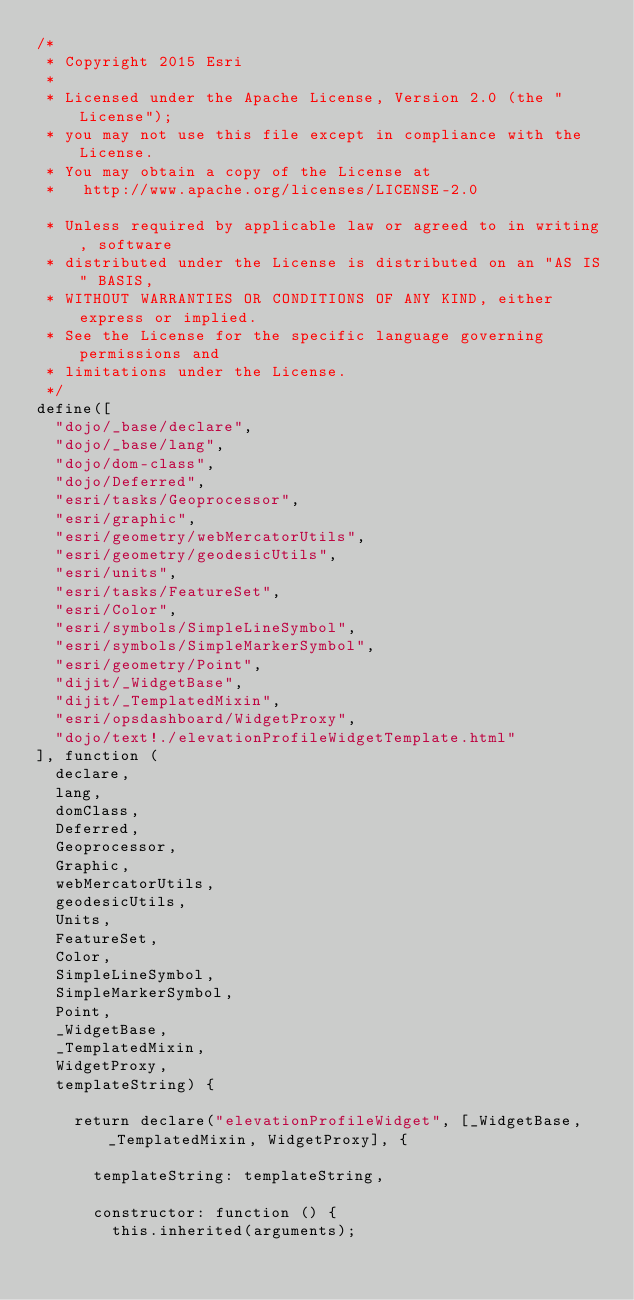Convert code to text. <code><loc_0><loc_0><loc_500><loc_500><_JavaScript_>/*
 * Copyright 2015 Esri
 *
 * Licensed under the Apache License, Version 2.0 (the "License");
 * you may not use this file except in compliance with the License.
 * You may obtain a copy of the License at
 *   http://www.apache.org/licenses/LICENSE-2.0

 * Unless required by applicable law or agreed to in writing, software
 * distributed under the License is distributed on an "AS IS" BASIS,
 * WITHOUT WARRANTIES OR CONDITIONS OF ANY KIND, either express or implied.
 * See the License for the specific language governing permissions and
 * limitations under the License.
 */
define([
  "dojo/_base/declare",
  "dojo/_base/lang",
  "dojo/dom-class",
  "dojo/Deferred",
  "esri/tasks/Geoprocessor",
  "esri/graphic",
  "esri/geometry/webMercatorUtils",
  "esri/geometry/geodesicUtils",
  "esri/units",
  "esri/tasks/FeatureSet",
  "esri/Color",
  "esri/symbols/SimpleLineSymbol",
  "esri/symbols/SimpleMarkerSymbol",
  "esri/geometry/Point",
  "dijit/_WidgetBase",
  "dijit/_TemplatedMixin",
  "esri/opsdashboard/WidgetProxy",
  "dojo/text!./elevationProfileWidgetTemplate.html"
], function (
  declare,
  lang,
  domClass,
  Deferred,
  Geoprocessor,
  Graphic,
  webMercatorUtils,
  geodesicUtils,
  Units,
  FeatureSet,
  Color,
  SimpleLineSymbol,
  SimpleMarkerSymbol,
  Point,
  _WidgetBase,
  _TemplatedMixin,
  WidgetProxy,
  templateString) {
    
    return declare("elevationProfileWidget", [_WidgetBase, _TemplatedMixin, WidgetProxy], {

      templateString: templateString,

      constructor: function () {
        this.inherited(arguments);
</code> 